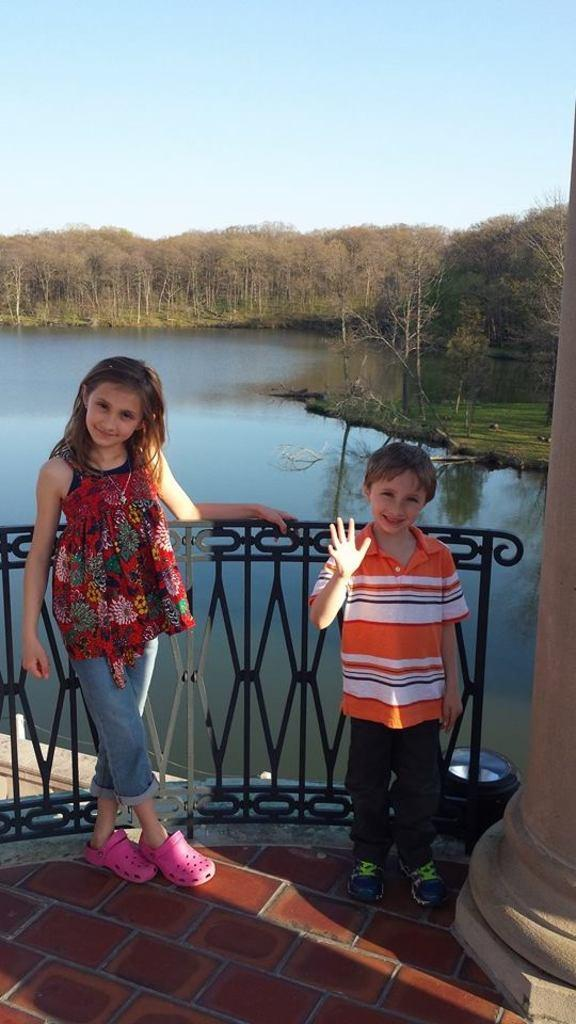How many people are present in the image? There is a girl and a boy in the image. What are the expressions of the girl and boy? The girl and boy are both smiling. What can be seen in the image besides the girl and boy? There is a grill and a pillar in the image. What is visible in the background of the image? Trees, grass, water, and the sky are visible in the background of the image. What type of act is the girl performing on the bridge in the image? There is no bridge present in the image, and the girl is not performing any act. How many fingers does the boy have on his left hand in the image? The image does not show the boy's fingers, so it cannot be determined how many fingers he has on his left hand. 